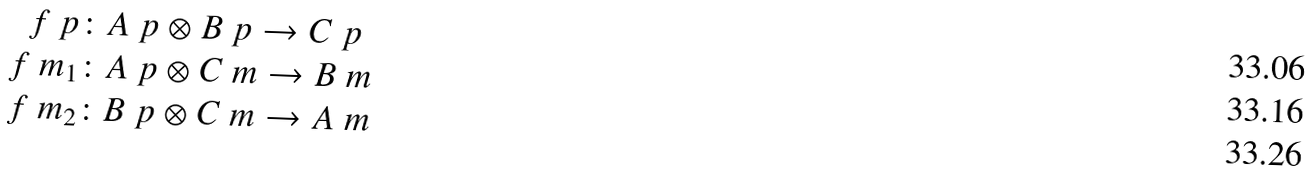Convert formula to latex. <formula><loc_0><loc_0><loc_500><loc_500>f \ p & \colon A \ p \otimes B \ p \to C \ p \\ f \ m _ { 1 } & \colon A \ p \otimes C \ m \to B \ m \\ f \ m _ { 2 } & \colon B \ p \otimes C \ m \to A \ m</formula> 